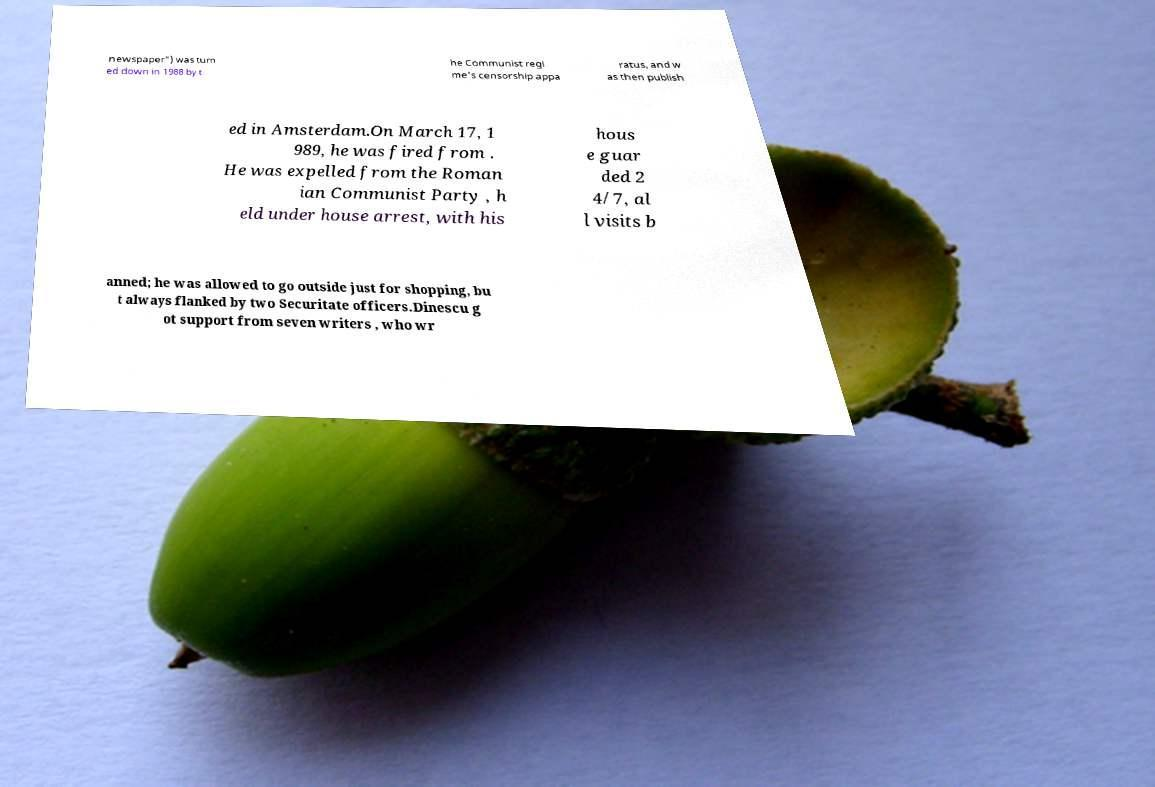What messages or text are displayed in this image? I need them in a readable, typed format. newspaper") was turn ed down in 1988 by t he Communist regi me's censorship appa ratus, and w as then publish ed in Amsterdam.On March 17, 1 989, he was fired from . He was expelled from the Roman ian Communist Party , h eld under house arrest, with his hous e guar ded 2 4/7, al l visits b anned; he was allowed to go outside just for shopping, bu t always flanked by two Securitate officers.Dinescu g ot support from seven writers , who wr 